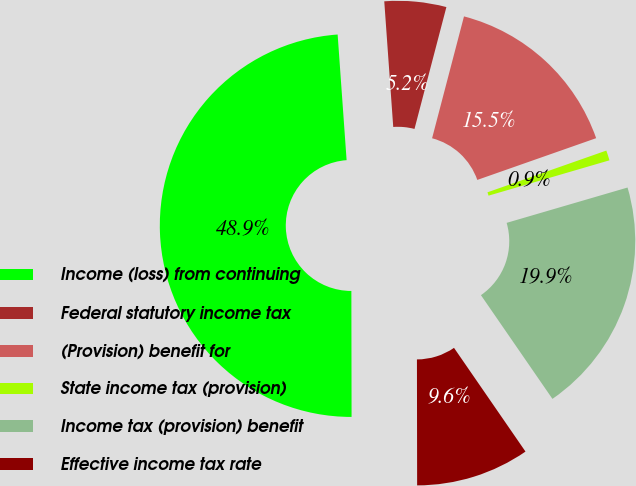<chart> <loc_0><loc_0><loc_500><loc_500><pie_chart><fcel>Income (loss) from continuing<fcel>Federal statutory income tax<fcel>(Provision) benefit for<fcel>State income tax (provision)<fcel>Income tax (provision) benefit<fcel>Effective income tax rate<nl><fcel>48.89%<fcel>5.21%<fcel>15.55%<fcel>0.85%<fcel>19.92%<fcel>9.58%<nl></chart> 